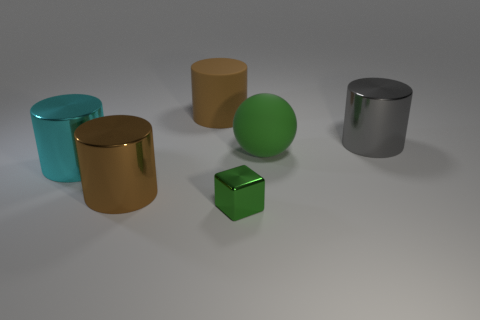Is there anything else that has the same size as the green metal cube?
Ensure brevity in your answer.  No. There is a shiny object that is to the right of the big rubber cylinder and in front of the green matte sphere; what shape is it?
Ensure brevity in your answer.  Cube. Is the size of the cyan cylinder the same as the matte cylinder?
Your answer should be compact. Yes. Is there a gray cylinder that has the same material as the cyan cylinder?
Your response must be concise. Yes. What is the size of the shiny thing that is the same color as the sphere?
Offer a terse response. Small. What number of big rubber objects are both in front of the gray metallic object and on the left side of the small green metal cube?
Provide a short and direct response. 0. What material is the brown thing that is left of the brown rubber cylinder?
Provide a short and direct response. Metal. What number of metal things are the same color as the big ball?
Keep it short and to the point. 1. What size is the green cube that is the same material as the large cyan cylinder?
Make the answer very short. Small. What number of objects are tiny blue blocks or big cyan metallic things?
Ensure brevity in your answer.  1. 